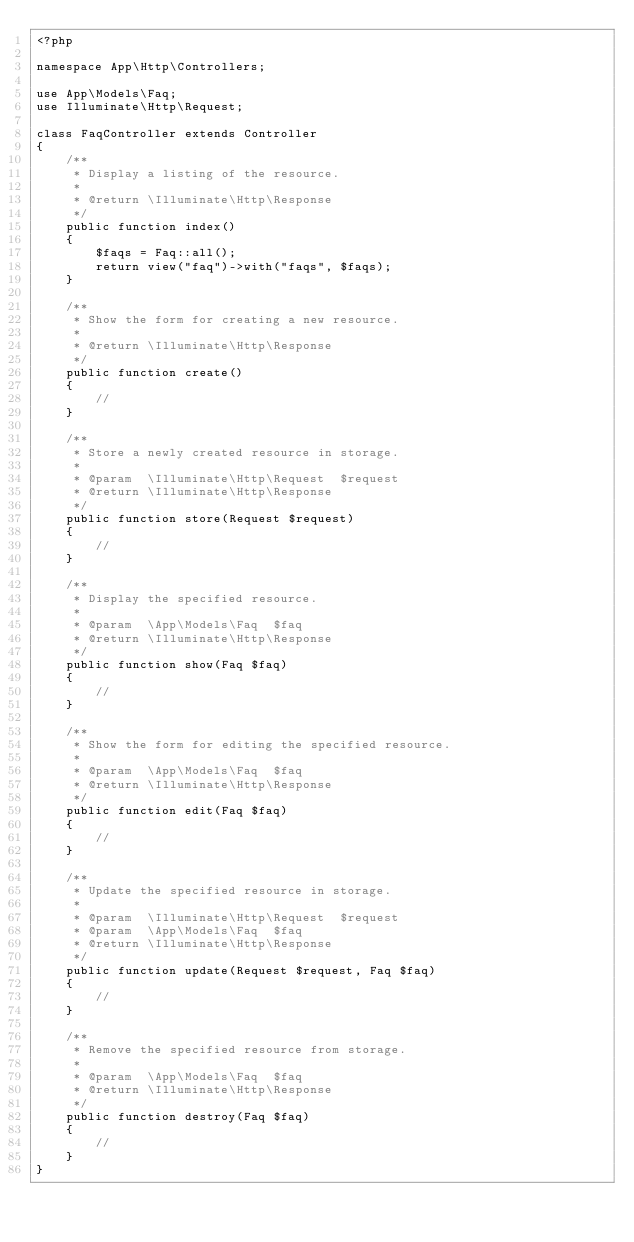Convert code to text. <code><loc_0><loc_0><loc_500><loc_500><_PHP_><?php

namespace App\Http\Controllers;

use App\Models\Faq;
use Illuminate\Http\Request;

class FaqController extends Controller
{
    /**
     * Display a listing of the resource.
     *
     * @return \Illuminate\Http\Response
     */
    public function index()
    {
        $faqs = Faq::all();
        return view("faq")->with("faqs", $faqs);
    }

    /**
     * Show the form for creating a new resource.
     *
     * @return \Illuminate\Http\Response
     */
    public function create()
    {
        //
    }

    /**
     * Store a newly created resource in storage.
     *
     * @param  \Illuminate\Http\Request  $request
     * @return \Illuminate\Http\Response
     */
    public function store(Request $request)
    {
        //
    }

    /**
     * Display the specified resource.
     *
     * @param  \App\Models\Faq  $faq
     * @return \Illuminate\Http\Response
     */
    public function show(Faq $faq)
    {
        //
    }

    /**
     * Show the form for editing the specified resource.
     *
     * @param  \App\Models\Faq  $faq
     * @return \Illuminate\Http\Response
     */
    public function edit(Faq $faq)
    {
        //
    }

    /**
     * Update the specified resource in storage.
     *
     * @param  \Illuminate\Http\Request  $request
     * @param  \App\Models\Faq  $faq
     * @return \Illuminate\Http\Response
     */
    public function update(Request $request, Faq $faq)
    {
        //
    }

    /**
     * Remove the specified resource from storage.
     *
     * @param  \App\Models\Faq  $faq
     * @return \Illuminate\Http\Response
     */
    public function destroy(Faq $faq)
    {
        //
    }
}
</code> 